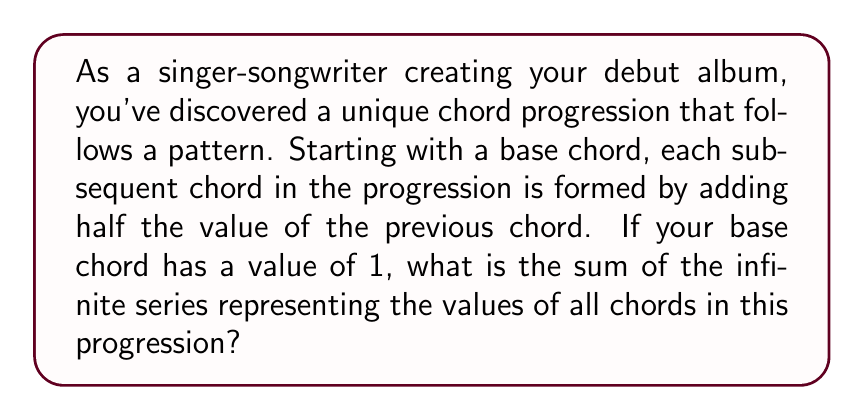Teach me how to tackle this problem. Let's approach this step-by-step:

1) First, let's identify the series. Given the description, we can write it as:

   $$ 1 + \frac{1}{2} + \frac{1}{4} + \frac{1}{8} + ... $$

2) This is a geometric series with first term $a = 1$ and common ratio $r = \frac{1}{2}$.

3) For an infinite geometric series, we can use the formula:

   $$ S_{\infty} = \frac{a}{1-r} $$

   where $S_{\infty}$ is the sum of the infinite series, $a$ is the first term, and $r$ is the common ratio.

4) Substituting our values:

   $$ S_{\infty} = \frac{1}{1-\frac{1}{2}} $$

5) Simplify the denominator:

   $$ S_{\infty} = \frac{1}{\frac{1}{2}} $$

6) Invert the fraction:

   $$ S_{\infty} = 2 $$

Thus, the sum of the infinite series representing your chord progression is 2.
Answer: 2 